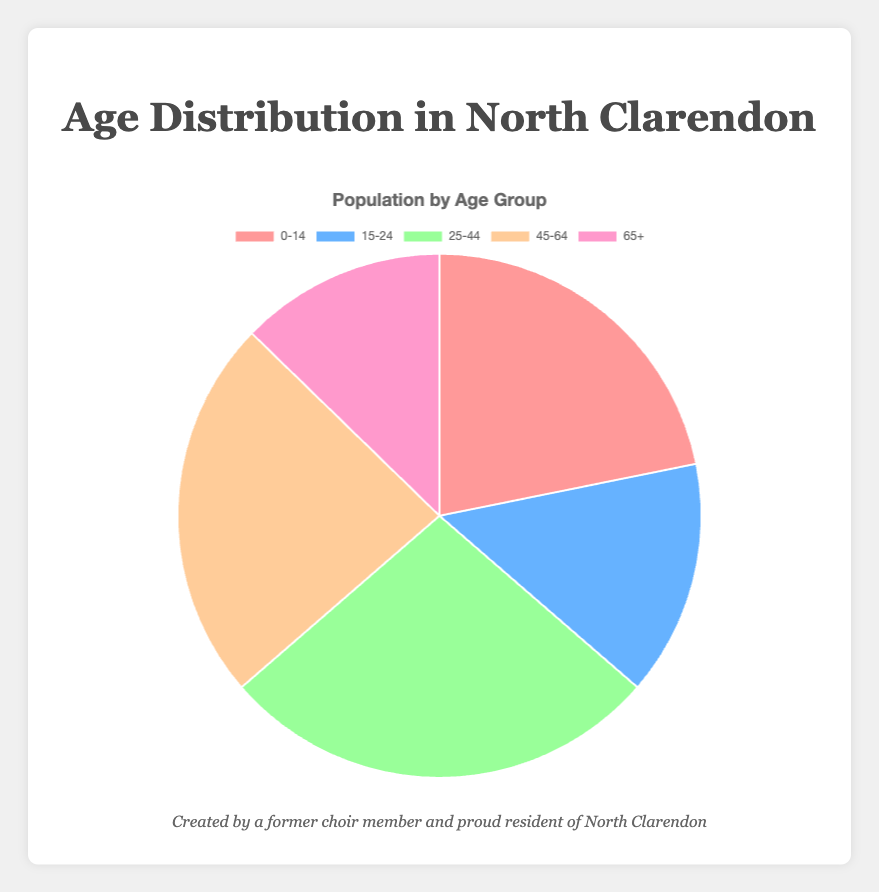What's the most populous age group in North Clarendon? Visual inspection shows that the slice representing the 25-44 age group is the largest among the five slices.
Answer: 25-44 Which age group has the smallest population? The smallest slice in the pie chart represents the 65+ age group, indicating it has the smallest population.
Answer: 65+ What is the total population of North Clarendon based on this chart? Adding up the populations of all age groups: 1200 + 800 + 1500 + 1300 + 700 = 5500.
Answer: 5500 How much larger is the population of the 25-44 age group compared to the 15-24 age group? Subtract the population of the 15-24 age group from the 25-44 age group: 1500 - 800 = 700.
Answer: 700 If you combine the populations of the 0-14 and 65+ age groups, what percentage of the total population do they represent? Sum of populations: 1200 + 700 = 1900. Total population = 5500. Percentage = (1900 / 5500) * 100 ≈ 34.55%.
Answer: 34.55% What fraction of the total population is in the 45-64 age group? The population in the 45-64 age group: 1300. Total population: 5500. Fraction = 1300 / 5500 = 13/55.
Answer: 13/55 Which age groups have a population greater than 1000? Age groups 0-14 (1200), 25-44 (1500), and 45-64 (1300) each have populations greater than 1000.
Answer: 0-14, 25-44, 45-64 Is the sum of the populations in the 15-24 and 65+ age groups greater than the population of the 25-44 age group? Sum of populations: 800 + 700 = 1500. Since 1500 equals the population of the 25-44 age group, the sum is not greater.
Answer: No How much of the chart is covered by the two most populous age groups? The 25-44 age group (1500) and the 45-64 age group (1300) have a combined population of 2800. Percentage = (2800 / 5500) * 100 ≈ 50.91%.
Answer: 50.91% What is the average population of the age groups? Total population: 5500. Number of age groups: 5. Average = 5500 / 5 = 1100.
Answer: 1100 